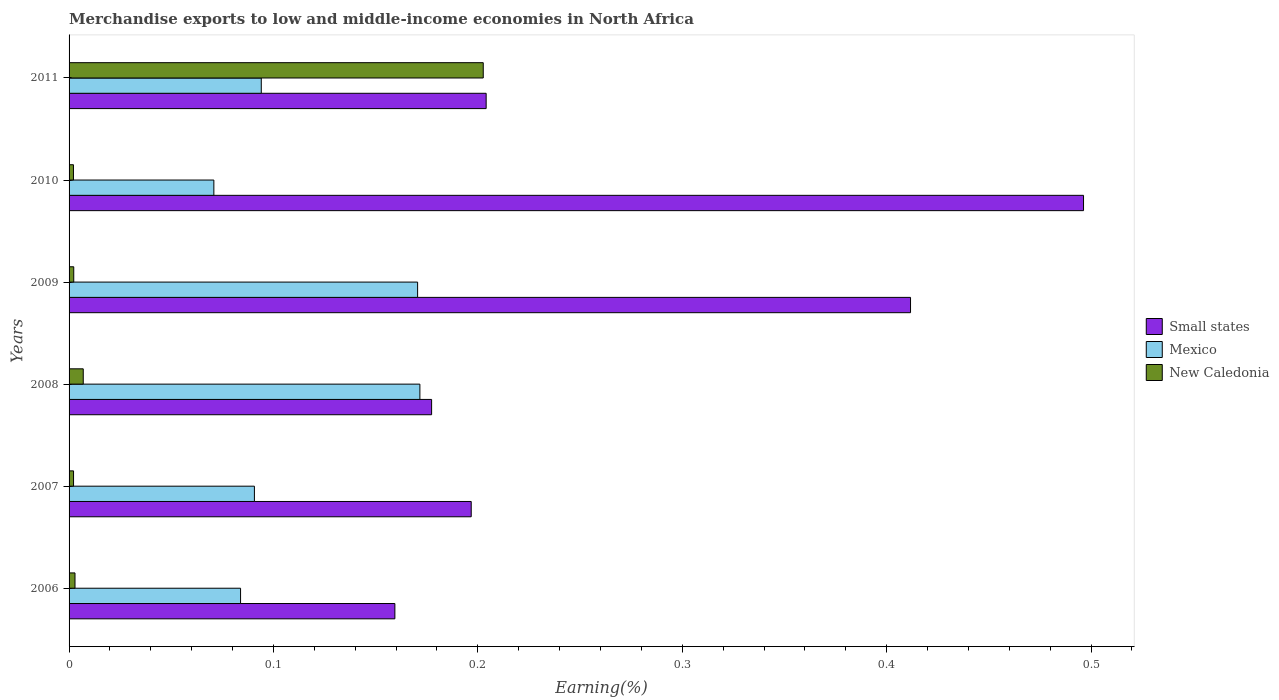How many different coloured bars are there?
Keep it short and to the point. 3. Are the number of bars on each tick of the Y-axis equal?
Keep it short and to the point. Yes. What is the label of the 5th group of bars from the top?
Provide a short and direct response. 2007. In how many cases, is the number of bars for a given year not equal to the number of legend labels?
Offer a terse response. 0. What is the percentage of amount earned from merchandise exports in Small states in 2008?
Give a very brief answer. 0.18. Across all years, what is the maximum percentage of amount earned from merchandise exports in New Caledonia?
Your answer should be compact. 0.2. Across all years, what is the minimum percentage of amount earned from merchandise exports in New Caledonia?
Provide a short and direct response. 0. In which year was the percentage of amount earned from merchandise exports in New Caledonia maximum?
Your answer should be compact. 2011. What is the total percentage of amount earned from merchandise exports in Small states in the graph?
Your response must be concise. 1.65. What is the difference between the percentage of amount earned from merchandise exports in Mexico in 2006 and that in 2007?
Offer a terse response. -0.01. What is the difference between the percentage of amount earned from merchandise exports in New Caledonia in 2008 and the percentage of amount earned from merchandise exports in Small states in 2007?
Offer a terse response. -0.19. What is the average percentage of amount earned from merchandise exports in Small states per year?
Give a very brief answer. 0.27. In the year 2007, what is the difference between the percentage of amount earned from merchandise exports in New Caledonia and percentage of amount earned from merchandise exports in Mexico?
Ensure brevity in your answer.  -0.09. What is the ratio of the percentage of amount earned from merchandise exports in Mexico in 2009 to that in 2011?
Provide a short and direct response. 1.81. Is the difference between the percentage of amount earned from merchandise exports in New Caledonia in 2006 and 2009 greater than the difference between the percentage of amount earned from merchandise exports in Mexico in 2006 and 2009?
Keep it short and to the point. Yes. What is the difference between the highest and the second highest percentage of amount earned from merchandise exports in New Caledonia?
Make the answer very short. 0.2. What is the difference between the highest and the lowest percentage of amount earned from merchandise exports in Small states?
Your answer should be compact. 0.34. In how many years, is the percentage of amount earned from merchandise exports in Small states greater than the average percentage of amount earned from merchandise exports in Small states taken over all years?
Provide a short and direct response. 2. How many bars are there?
Your answer should be very brief. 18. Are all the bars in the graph horizontal?
Make the answer very short. Yes. How many years are there in the graph?
Give a very brief answer. 6. What is the difference between two consecutive major ticks on the X-axis?
Give a very brief answer. 0.1. Are the values on the major ticks of X-axis written in scientific E-notation?
Your answer should be compact. No. Does the graph contain any zero values?
Provide a short and direct response. No. Does the graph contain grids?
Provide a succinct answer. No. How many legend labels are there?
Give a very brief answer. 3. What is the title of the graph?
Your answer should be compact. Merchandise exports to low and middle-income economies in North Africa. What is the label or title of the X-axis?
Offer a terse response. Earning(%). What is the Earning(%) of Small states in 2006?
Make the answer very short. 0.16. What is the Earning(%) of Mexico in 2006?
Ensure brevity in your answer.  0.08. What is the Earning(%) in New Caledonia in 2006?
Keep it short and to the point. 0. What is the Earning(%) of Small states in 2007?
Offer a very short reply. 0.2. What is the Earning(%) in Mexico in 2007?
Give a very brief answer. 0.09. What is the Earning(%) in New Caledonia in 2007?
Ensure brevity in your answer.  0. What is the Earning(%) in Small states in 2008?
Give a very brief answer. 0.18. What is the Earning(%) in Mexico in 2008?
Ensure brevity in your answer.  0.17. What is the Earning(%) in New Caledonia in 2008?
Provide a short and direct response. 0.01. What is the Earning(%) in Small states in 2009?
Offer a very short reply. 0.41. What is the Earning(%) of Mexico in 2009?
Offer a terse response. 0.17. What is the Earning(%) in New Caledonia in 2009?
Provide a succinct answer. 0. What is the Earning(%) of Small states in 2010?
Provide a succinct answer. 0.5. What is the Earning(%) of Mexico in 2010?
Provide a succinct answer. 0.07. What is the Earning(%) in New Caledonia in 2010?
Ensure brevity in your answer.  0. What is the Earning(%) in Small states in 2011?
Your answer should be compact. 0.2. What is the Earning(%) in Mexico in 2011?
Your response must be concise. 0.09. What is the Earning(%) in New Caledonia in 2011?
Your answer should be compact. 0.2. Across all years, what is the maximum Earning(%) in Small states?
Ensure brevity in your answer.  0.5. Across all years, what is the maximum Earning(%) of Mexico?
Offer a very short reply. 0.17. Across all years, what is the maximum Earning(%) of New Caledonia?
Provide a succinct answer. 0.2. Across all years, what is the minimum Earning(%) in Small states?
Give a very brief answer. 0.16. Across all years, what is the minimum Earning(%) in Mexico?
Keep it short and to the point. 0.07. Across all years, what is the minimum Earning(%) of New Caledonia?
Provide a short and direct response. 0. What is the total Earning(%) in Small states in the graph?
Give a very brief answer. 1.65. What is the total Earning(%) of Mexico in the graph?
Your response must be concise. 0.68. What is the total Earning(%) in New Caledonia in the graph?
Keep it short and to the point. 0.22. What is the difference between the Earning(%) of Small states in 2006 and that in 2007?
Give a very brief answer. -0.04. What is the difference between the Earning(%) in Mexico in 2006 and that in 2007?
Your response must be concise. -0.01. What is the difference between the Earning(%) of New Caledonia in 2006 and that in 2007?
Your answer should be compact. 0. What is the difference between the Earning(%) in Small states in 2006 and that in 2008?
Make the answer very short. -0.02. What is the difference between the Earning(%) of Mexico in 2006 and that in 2008?
Make the answer very short. -0.09. What is the difference between the Earning(%) in New Caledonia in 2006 and that in 2008?
Your response must be concise. -0. What is the difference between the Earning(%) in Small states in 2006 and that in 2009?
Provide a short and direct response. -0.25. What is the difference between the Earning(%) of Mexico in 2006 and that in 2009?
Give a very brief answer. -0.09. What is the difference between the Earning(%) of New Caledonia in 2006 and that in 2009?
Your answer should be very brief. 0. What is the difference between the Earning(%) in Small states in 2006 and that in 2010?
Your answer should be compact. -0.34. What is the difference between the Earning(%) in Mexico in 2006 and that in 2010?
Your answer should be very brief. 0.01. What is the difference between the Earning(%) in New Caledonia in 2006 and that in 2010?
Your response must be concise. 0. What is the difference between the Earning(%) of Small states in 2006 and that in 2011?
Offer a terse response. -0.04. What is the difference between the Earning(%) of Mexico in 2006 and that in 2011?
Your answer should be compact. -0.01. What is the difference between the Earning(%) in New Caledonia in 2006 and that in 2011?
Provide a succinct answer. -0.2. What is the difference between the Earning(%) of Small states in 2007 and that in 2008?
Your answer should be compact. 0.02. What is the difference between the Earning(%) in Mexico in 2007 and that in 2008?
Your response must be concise. -0.08. What is the difference between the Earning(%) of New Caledonia in 2007 and that in 2008?
Your response must be concise. -0. What is the difference between the Earning(%) of Small states in 2007 and that in 2009?
Provide a short and direct response. -0.21. What is the difference between the Earning(%) in Mexico in 2007 and that in 2009?
Make the answer very short. -0.08. What is the difference between the Earning(%) in New Caledonia in 2007 and that in 2009?
Your response must be concise. -0. What is the difference between the Earning(%) of Small states in 2007 and that in 2010?
Make the answer very short. -0.3. What is the difference between the Earning(%) of Mexico in 2007 and that in 2010?
Offer a terse response. 0.02. What is the difference between the Earning(%) of New Caledonia in 2007 and that in 2010?
Give a very brief answer. 0. What is the difference between the Earning(%) of Small states in 2007 and that in 2011?
Give a very brief answer. -0.01. What is the difference between the Earning(%) of Mexico in 2007 and that in 2011?
Your response must be concise. -0. What is the difference between the Earning(%) of New Caledonia in 2007 and that in 2011?
Your answer should be compact. -0.2. What is the difference between the Earning(%) in Small states in 2008 and that in 2009?
Ensure brevity in your answer.  -0.23. What is the difference between the Earning(%) in Mexico in 2008 and that in 2009?
Your answer should be very brief. 0. What is the difference between the Earning(%) of New Caledonia in 2008 and that in 2009?
Keep it short and to the point. 0. What is the difference between the Earning(%) in Small states in 2008 and that in 2010?
Provide a succinct answer. -0.32. What is the difference between the Earning(%) in Mexico in 2008 and that in 2010?
Provide a succinct answer. 0.1. What is the difference between the Earning(%) of New Caledonia in 2008 and that in 2010?
Make the answer very short. 0. What is the difference between the Earning(%) in Small states in 2008 and that in 2011?
Make the answer very short. -0.03. What is the difference between the Earning(%) in Mexico in 2008 and that in 2011?
Provide a succinct answer. 0.08. What is the difference between the Earning(%) in New Caledonia in 2008 and that in 2011?
Make the answer very short. -0.2. What is the difference between the Earning(%) in Small states in 2009 and that in 2010?
Offer a very short reply. -0.08. What is the difference between the Earning(%) in Mexico in 2009 and that in 2010?
Offer a terse response. 0.1. What is the difference between the Earning(%) of New Caledonia in 2009 and that in 2010?
Make the answer very short. 0. What is the difference between the Earning(%) in Small states in 2009 and that in 2011?
Make the answer very short. 0.21. What is the difference between the Earning(%) of Mexico in 2009 and that in 2011?
Provide a short and direct response. 0.08. What is the difference between the Earning(%) of New Caledonia in 2009 and that in 2011?
Ensure brevity in your answer.  -0.2. What is the difference between the Earning(%) of Small states in 2010 and that in 2011?
Offer a very short reply. 0.29. What is the difference between the Earning(%) of Mexico in 2010 and that in 2011?
Keep it short and to the point. -0.02. What is the difference between the Earning(%) of New Caledonia in 2010 and that in 2011?
Offer a terse response. -0.2. What is the difference between the Earning(%) of Small states in 2006 and the Earning(%) of Mexico in 2007?
Offer a terse response. 0.07. What is the difference between the Earning(%) in Small states in 2006 and the Earning(%) in New Caledonia in 2007?
Provide a succinct answer. 0.16. What is the difference between the Earning(%) in Mexico in 2006 and the Earning(%) in New Caledonia in 2007?
Provide a short and direct response. 0.08. What is the difference between the Earning(%) of Small states in 2006 and the Earning(%) of Mexico in 2008?
Give a very brief answer. -0.01. What is the difference between the Earning(%) in Small states in 2006 and the Earning(%) in New Caledonia in 2008?
Ensure brevity in your answer.  0.15. What is the difference between the Earning(%) in Mexico in 2006 and the Earning(%) in New Caledonia in 2008?
Provide a short and direct response. 0.08. What is the difference between the Earning(%) in Small states in 2006 and the Earning(%) in Mexico in 2009?
Your answer should be compact. -0.01. What is the difference between the Earning(%) in Small states in 2006 and the Earning(%) in New Caledonia in 2009?
Make the answer very short. 0.16. What is the difference between the Earning(%) of Mexico in 2006 and the Earning(%) of New Caledonia in 2009?
Give a very brief answer. 0.08. What is the difference between the Earning(%) in Small states in 2006 and the Earning(%) in Mexico in 2010?
Offer a very short reply. 0.09. What is the difference between the Earning(%) of Small states in 2006 and the Earning(%) of New Caledonia in 2010?
Your answer should be compact. 0.16. What is the difference between the Earning(%) of Mexico in 2006 and the Earning(%) of New Caledonia in 2010?
Offer a terse response. 0.08. What is the difference between the Earning(%) of Small states in 2006 and the Earning(%) of Mexico in 2011?
Your answer should be compact. 0.07. What is the difference between the Earning(%) of Small states in 2006 and the Earning(%) of New Caledonia in 2011?
Ensure brevity in your answer.  -0.04. What is the difference between the Earning(%) in Mexico in 2006 and the Earning(%) in New Caledonia in 2011?
Keep it short and to the point. -0.12. What is the difference between the Earning(%) in Small states in 2007 and the Earning(%) in Mexico in 2008?
Make the answer very short. 0.03. What is the difference between the Earning(%) of Small states in 2007 and the Earning(%) of New Caledonia in 2008?
Keep it short and to the point. 0.19. What is the difference between the Earning(%) of Mexico in 2007 and the Earning(%) of New Caledonia in 2008?
Ensure brevity in your answer.  0.08. What is the difference between the Earning(%) of Small states in 2007 and the Earning(%) of Mexico in 2009?
Provide a short and direct response. 0.03. What is the difference between the Earning(%) of Small states in 2007 and the Earning(%) of New Caledonia in 2009?
Your answer should be very brief. 0.19. What is the difference between the Earning(%) of Mexico in 2007 and the Earning(%) of New Caledonia in 2009?
Provide a short and direct response. 0.09. What is the difference between the Earning(%) in Small states in 2007 and the Earning(%) in Mexico in 2010?
Your answer should be compact. 0.13. What is the difference between the Earning(%) in Small states in 2007 and the Earning(%) in New Caledonia in 2010?
Keep it short and to the point. 0.19. What is the difference between the Earning(%) of Mexico in 2007 and the Earning(%) of New Caledonia in 2010?
Provide a succinct answer. 0.09. What is the difference between the Earning(%) in Small states in 2007 and the Earning(%) in Mexico in 2011?
Keep it short and to the point. 0.1. What is the difference between the Earning(%) of Small states in 2007 and the Earning(%) of New Caledonia in 2011?
Your answer should be very brief. -0.01. What is the difference between the Earning(%) in Mexico in 2007 and the Earning(%) in New Caledonia in 2011?
Make the answer very short. -0.11. What is the difference between the Earning(%) of Small states in 2008 and the Earning(%) of Mexico in 2009?
Your response must be concise. 0.01. What is the difference between the Earning(%) in Small states in 2008 and the Earning(%) in New Caledonia in 2009?
Make the answer very short. 0.18. What is the difference between the Earning(%) in Mexico in 2008 and the Earning(%) in New Caledonia in 2009?
Provide a short and direct response. 0.17. What is the difference between the Earning(%) of Small states in 2008 and the Earning(%) of Mexico in 2010?
Your answer should be compact. 0.11. What is the difference between the Earning(%) in Small states in 2008 and the Earning(%) in New Caledonia in 2010?
Your answer should be compact. 0.18. What is the difference between the Earning(%) of Mexico in 2008 and the Earning(%) of New Caledonia in 2010?
Provide a succinct answer. 0.17. What is the difference between the Earning(%) in Small states in 2008 and the Earning(%) in Mexico in 2011?
Keep it short and to the point. 0.08. What is the difference between the Earning(%) of Small states in 2008 and the Earning(%) of New Caledonia in 2011?
Offer a terse response. -0.03. What is the difference between the Earning(%) in Mexico in 2008 and the Earning(%) in New Caledonia in 2011?
Give a very brief answer. -0.03. What is the difference between the Earning(%) of Small states in 2009 and the Earning(%) of Mexico in 2010?
Ensure brevity in your answer.  0.34. What is the difference between the Earning(%) of Small states in 2009 and the Earning(%) of New Caledonia in 2010?
Provide a succinct answer. 0.41. What is the difference between the Earning(%) of Mexico in 2009 and the Earning(%) of New Caledonia in 2010?
Your answer should be compact. 0.17. What is the difference between the Earning(%) in Small states in 2009 and the Earning(%) in Mexico in 2011?
Provide a short and direct response. 0.32. What is the difference between the Earning(%) in Small states in 2009 and the Earning(%) in New Caledonia in 2011?
Provide a short and direct response. 0.21. What is the difference between the Earning(%) in Mexico in 2009 and the Earning(%) in New Caledonia in 2011?
Give a very brief answer. -0.03. What is the difference between the Earning(%) in Small states in 2010 and the Earning(%) in Mexico in 2011?
Offer a terse response. 0.4. What is the difference between the Earning(%) in Small states in 2010 and the Earning(%) in New Caledonia in 2011?
Your answer should be compact. 0.29. What is the difference between the Earning(%) of Mexico in 2010 and the Earning(%) of New Caledonia in 2011?
Ensure brevity in your answer.  -0.13. What is the average Earning(%) of Small states per year?
Your answer should be very brief. 0.27. What is the average Earning(%) in Mexico per year?
Provide a short and direct response. 0.11. What is the average Earning(%) of New Caledonia per year?
Your answer should be very brief. 0.04. In the year 2006, what is the difference between the Earning(%) in Small states and Earning(%) in Mexico?
Provide a short and direct response. 0.08. In the year 2006, what is the difference between the Earning(%) in Small states and Earning(%) in New Caledonia?
Keep it short and to the point. 0.16. In the year 2006, what is the difference between the Earning(%) in Mexico and Earning(%) in New Caledonia?
Offer a terse response. 0.08. In the year 2007, what is the difference between the Earning(%) of Small states and Earning(%) of Mexico?
Keep it short and to the point. 0.11. In the year 2007, what is the difference between the Earning(%) of Small states and Earning(%) of New Caledonia?
Your response must be concise. 0.19. In the year 2007, what is the difference between the Earning(%) of Mexico and Earning(%) of New Caledonia?
Keep it short and to the point. 0.09. In the year 2008, what is the difference between the Earning(%) in Small states and Earning(%) in Mexico?
Ensure brevity in your answer.  0.01. In the year 2008, what is the difference between the Earning(%) of Small states and Earning(%) of New Caledonia?
Keep it short and to the point. 0.17. In the year 2008, what is the difference between the Earning(%) of Mexico and Earning(%) of New Caledonia?
Provide a short and direct response. 0.16. In the year 2009, what is the difference between the Earning(%) in Small states and Earning(%) in Mexico?
Keep it short and to the point. 0.24. In the year 2009, what is the difference between the Earning(%) of Small states and Earning(%) of New Caledonia?
Your response must be concise. 0.41. In the year 2009, what is the difference between the Earning(%) in Mexico and Earning(%) in New Caledonia?
Keep it short and to the point. 0.17. In the year 2010, what is the difference between the Earning(%) in Small states and Earning(%) in Mexico?
Make the answer very short. 0.43. In the year 2010, what is the difference between the Earning(%) of Small states and Earning(%) of New Caledonia?
Your answer should be compact. 0.49. In the year 2010, what is the difference between the Earning(%) of Mexico and Earning(%) of New Caledonia?
Your answer should be compact. 0.07. In the year 2011, what is the difference between the Earning(%) in Small states and Earning(%) in Mexico?
Offer a very short reply. 0.11. In the year 2011, what is the difference between the Earning(%) in Small states and Earning(%) in New Caledonia?
Provide a short and direct response. 0. In the year 2011, what is the difference between the Earning(%) of Mexico and Earning(%) of New Caledonia?
Your answer should be very brief. -0.11. What is the ratio of the Earning(%) in Small states in 2006 to that in 2007?
Offer a very short reply. 0.81. What is the ratio of the Earning(%) of Mexico in 2006 to that in 2007?
Offer a very short reply. 0.93. What is the ratio of the Earning(%) in New Caledonia in 2006 to that in 2007?
Your response must be concise. 1.32. What is the ratio of the Earning(%) in Small states in 2006 to that in 2008?
Your answer should be compact. 0.9. What is the ratio of the Earning(%) in Mexico in 2006 to that in 2008?
Offer a very short reply. 0.49. What is the ratio of the Earning(%) in New Caledonia in 2006 to that in 2008?
Offer a terse response. 0.42. What is the ratio of the Earning(%) of Small states in 2006 to that in 2009?
Offer a very short reply. 0.39. What is the ratio of the Earning(%) in Mexico in 2006 to that in 2009?
Give a very brief answer. 0.49. What is the ratio of the Earning(%) in New Caledonia in 2006 to that in 2009?
Make the answer very short. 1.27. What is the ratio of the Earning(%) of Small states in 2006 to that in 2010?
Offer a very short reply. 0.32. What is the ratio of the Earning(%) in Mexico in 2006 to that in 2010?
Offer a very short reply. 1.18. What is the ratio of the Earning(%) in New Caledonia in 2006 to that in 2010?
Keep it short and to the point. 1.35. What is the ratio of the Earning(%) in Small states in 2006 to that in 2011?
Ensure brevity in your answer.  0.78. What is the ratio of the Earning(%) of Mexico in 2006 to that in 2011?
Your answer should be compact. 0.89. What is the ratio of the Earning(%) of New Caledonia in 2006 to that in 2011?
Offer a terse response. 0.01. What is the ratio of the Earning(%) in Small states in 2007 to that in 2008?
Give a very brief answer. 1.11. What is the ratio of the Earning(%) of Mexico in 2007 to that in 2008?
Give a very brief answer. 0.53. What is the ratio of the Earning(%) of New Caledonia in 2007 to that in 2008?
Keep it short and to the point. 0.32. What is the ratio of the Earning(%) in Small states in 2007 to that in 2009?
Provide a short and direct response. 0.48. What is the ratio of the Earning(%) in Mexico in 2007 to that in 2009?
Provide a succinct answer. 0.53. What is the ratio of the Earning(%) in Small states in 2007 to that in 2010?
Your response must be concise. 0.4. What is the ratio of the Earning(%) of Mexico in 2007 to that in 2010?
Offer a terse response. 1.28. What is the ratio of the Earning(%) in Small states in 2007 to that in 2011?
Your answer should be compact. 0.96. What is the ratio of the Earning(%) of Mexico in 2007 to that in 2011?
Your answer should be very brief. 0.96. What is the ratio of the Earning(%) of New Caledonia in 2007 to that in 2011?
Ensure brevity in your answer.  0.01. What is the ratio of the Earning(%) of Small states in 2008 to that in 2009?
Ensure brevity in your answer.  0.43. What is the ratio of the Earning(%) in Mexico in 2008 to that in 2009?
Ensure brevity in your answer.  1.01. What is the ratio of the Earning(%) in New Caledonia in 2008 to that in 2009?
Keep it short and to the point. 3.03. What is the ratio of the Earning(%) of Small states in 2008 to that in 2010?
Provide a short and direct response. 0.36. What is the ratio of the Earning(%) of Mexico in 2008 to that in 2010?
Your answer should be very brief. 2.42. What is the ratio of the Earning(%) in New Caledonia in 2008 to that in 2010?
Offer a very short reply. 3.24. What is the ratio of the Earning(%) in Small states in 2008 to that in 2011?
Offer a very short reply. 0.87. What is the ratio of the Earning(%) of Mexico in 2008 to that in 2011?
Your answer should be very brief. 1.83. What is the ratio of the Earning(%) of New Caledonia in 2008 to that in 2011?
Keep it short and to the point. 0.03. What is the ratio of the Earning(%) in Small states in 2009 to that in 2010?
Give a very brief answer. 0.83. What is the ratio of the Earning(%) in Mexico in 2009 to that in 2010?
Provide a succinct answer. 2.41. What is the ratio of the Earning(%) of New Caledonia in 2009 to that in 2010?
Ensure brevity in your answer.  1.07. What is the ratio of the Earning(%) in Small states in 2009 to that in 2011?
Your response must be concise. 2.02. What is the ratio of the Earning(%) of Mexico in 2009 to that in 2011?
Your answer should be compact. 1.81. What is the ratio of the Earning(%) of New Caledonia in 2009 to that in 2011?
Keep it short and to the point. 0.01. What is the ratio of the Earning(%) in Small states in 2010 to that in 2011?
Your response must be concise. 2.43. What is the ratio of the Earning(%) of Mexico in 2010 to that in 2011?
Make the answer very short. 0.75. What is the ratio of the Earning(%) in New Caledonia in 2010 to that in 2011?
Offer a terse response. 0.01. What is the difference between the highest and the second highest Earning(%) in Small states?
Keep it short and to the point. 0.08. What is the difference between the highest and the second highest Earning(%) in Mexico?
Offer a very short reply. 0. What is the difference between the highest and the second highest Earning(%) of New Caledonia?
Provide a short and direct response. 0.2. What is the difference between the highest and the lowest Earning(%) of Small states?
Make the answer very short. 0.34. What is the difference between the highest and the lowest Earning(%) of Mexico?
Make the answer very short. 0.1. What is the difference between the highest and the lowest Earning(%) of New Caledonia?
Offer a terse response. 0.2. 